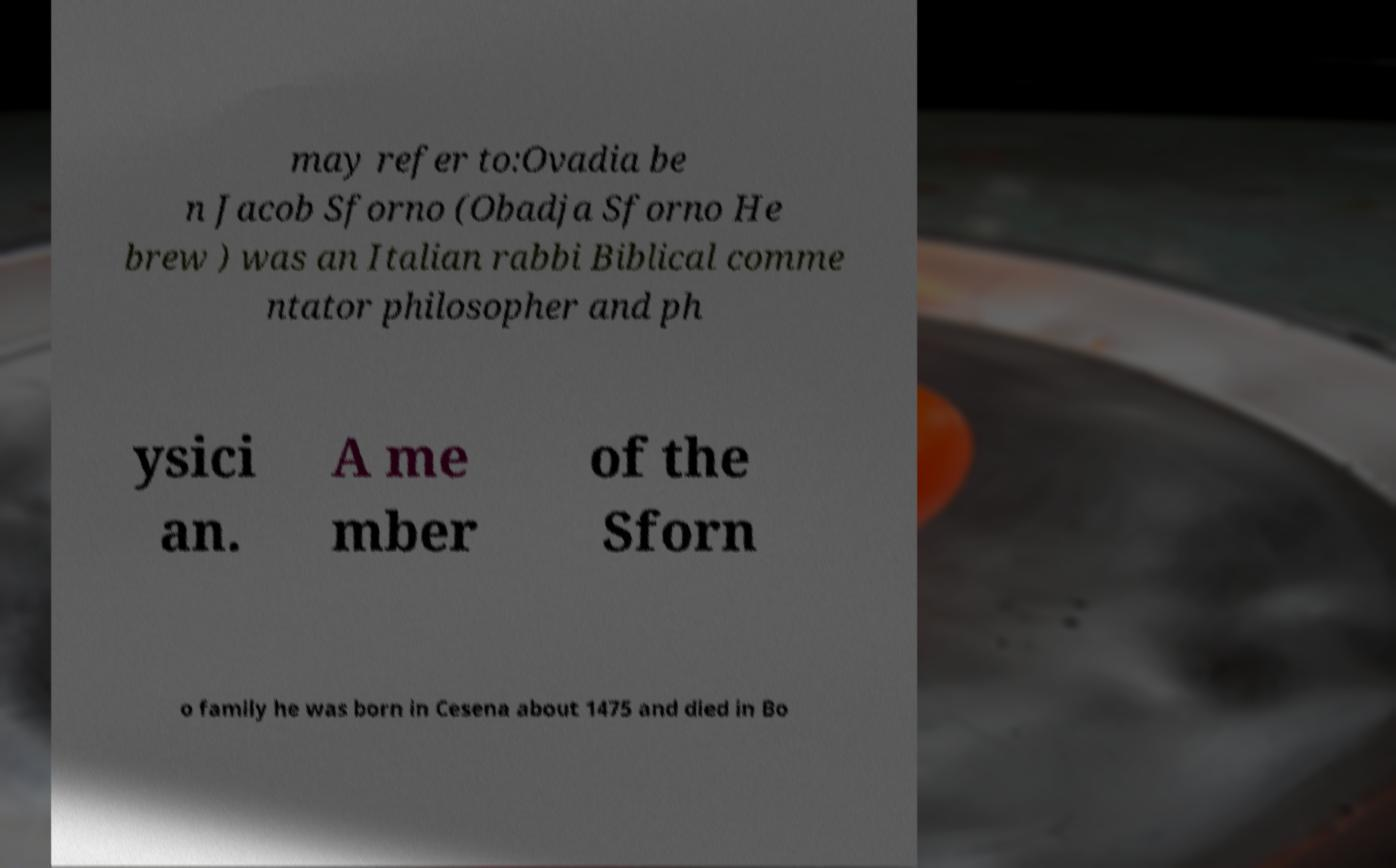What messages or text are displayed in this image? I need them in a readable, typed format. may refer to:Ovadia be n Jacob Sforno (Obadja Sforno He brew ) was an Italian rabbi Biblical comme ntator philosopher and ph ysici an. A me mber of the Sforn o family he was born in Cesena about 1475 and died in Bo 